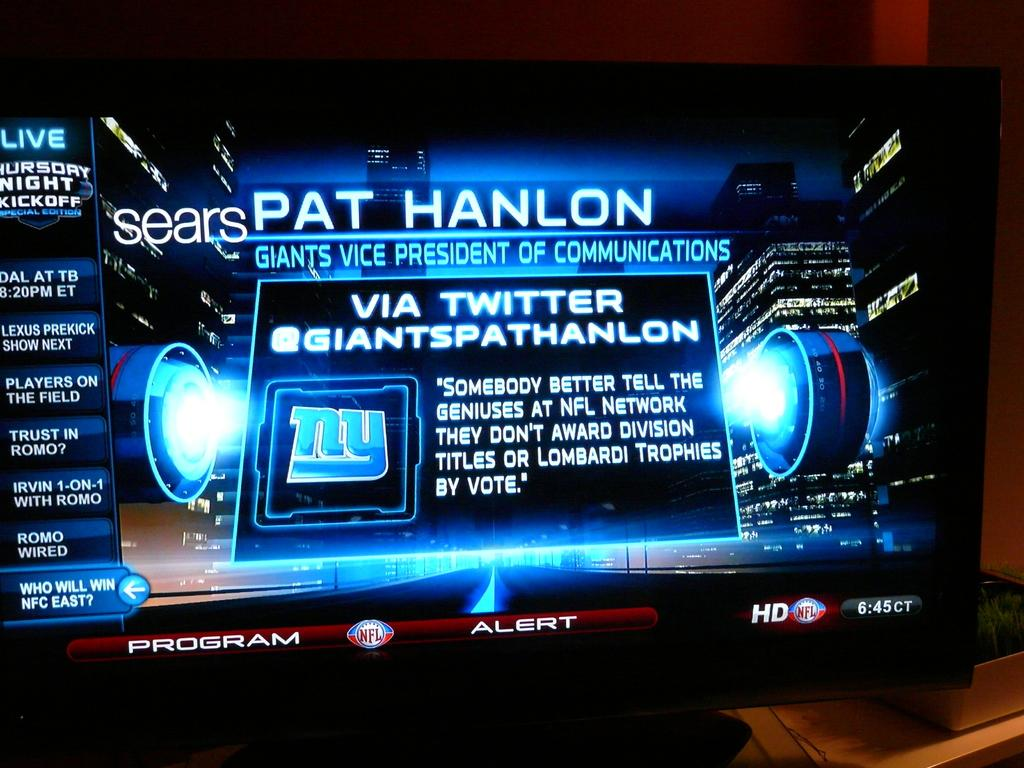Provide a one-sentence caption for the provided image. A neon billboard with the title Pat Hanlon Giants Vice President of Communications on it. 